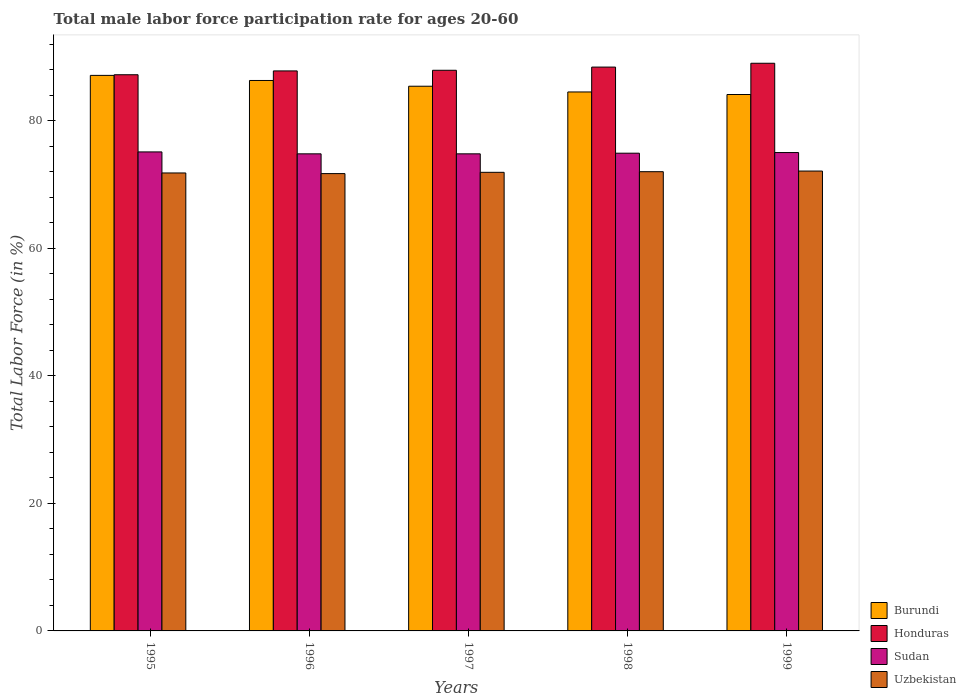Are the number of bars per tick equal to the number of legend labels?
Your answer should be compact. Yes. Are the number of bars on each tick of the X-axis equal?
Your response must be concise. Yes. How many bars are there on the 5th tick from the left?
Ensure brevity in your answer.  4. How many bars are there on the 5th tick from the right?
Your answer should be very brief. 4. What is the male labor force participation rate in Honduras in 1997?
Make the answer very short. 87.9. Across all years, what is the maximum male labor force participation rate in Uzbekistan?
Keep it short and to the point. 72.1. Across all years, what is the minimum male labor force participation rate in Burundi?
Provide a succinct answer. 84.1. In which year was the male labor force participation rate in Honduras maximum?
Keep it short and to the point. 1999. In which year was the male labor force participation rate in Burundi minimum?
Give a very brief answer. 1999. What is the total male labor force participation rate in Burundi in the graph?
Provide a short and direct response. 427.4. What is the difference between the male labor force participation rate in Honduras in 1995 and that in 1996?
Provide a succinct answer. -0.6. What is the difference between the male labor force participation rate in Sudan in 1997 and the male labor force participation rate in Burundi in 1995?
Your answer should be very brief. -12.3. What is the average male labor force participation rate in Sudan per year?
Keep it short and to the point. 74.92. In the year 1998, what is the difference between the male labor force participation rate in Uzbekistan and male labor force participation rate in Honduras?
Keep it short and to the point. -16.4. What is the ratio of the male labor force participation rate in Uzbekistan in 1995 to that in 1997?
Provide a short and direct response. 1. Is the difference between the male labor force participation rate in Uzbekistan in 1996 and 1998 greater than the difference between the male labor force participation rate in Honduras in 1996 and 1998?
Ensure brevity in your answer.  Yes. What is the difference between the highest and the second highest male labor force participation rate in Sudan?
Keep it short and to the point. 0.1. What is the difference between the highest and the lowest male labor force participation rate in Sudan?
Keep it short and to the point. 0.3. Is it the case that in every year, the sum of the male labor force participation rate in Honduras and male labor force participation rate in Sudan is greater than the sum of male labor force participation rate in Burundi and male labor force participation rate in Uzbekistan?
Make the answer very short. No. What does the 3rd bar from the left in 1997 represents?
Your answer should be very brief. Sudan. What does the 4th bar from the right in 1998 represents?
Provide a succinct answer. Burundi. Are all the bars in the graph horizontal?
Your answer should be compact. No. How many years are there in the graph?
Make the answer very short. 5. Does the graph contain any zero values?
Make the answer very short. No. What is the title of the graph?
Offer a very short reply. Total male labor force participation rate for ages 20-60. What is the Total Labor Force (in %) in Burundi in 1995?
Provide a succinct answer. 87.1. What is the Total Labor Force (in %) of Honduras in 1995?
Offer a terse response. 87.2. What is the Total Labor Force (in %) of Sudan in 1995?
Make the answer very short. 75.1. What is the Total Labor Force (in %) in Uzbekistan in 1995?
Offer a terse response. 71.8. What is the Total Labor Force (in %) of Burundi in 1996?
Offer a terse response. 86.3. What is the Total Labor Force (in %) in Honduras in 1996?
Give a very brief answer. 87.8. What is the Total Labor Force (in %) in Sudan in 1996?
Offer a very short reply. 74.8. What is the Total Labor Force (in %) of Uzbekistan in 1996?
Provide a short and direct response. 71.7. What is the Total Labor Force (in %) in Burundi in 1997?
Provide a short and direct response. 85.4. What is the Total Labor Force (in %) of Honduras in 1997?
Your answer should be very brief. 87.9. What is the Total Labor Force (in %) of Sudan in 1997?
Provide a short and direct response. 74.8. What is the Total Labor Force (in %) in Uzbekistan in 1997?
Your response must be concise. 71.9. What is the Total Labor Force (in %) in Burundi in 1998?
Provide a short and direct response. 84.5. What is the Total Labor Force (in %) of Honduras in 1998?
Ensure brevity in your answer.  88.4. What is the Total Labor Force (in %) in Sudan in 1998?
Ensure brevity in your answer.  74.9. What is the Total Labor Force (in %) in Uzbekistan in 1998?
Your answer should be compact. 72. What is the Total Labor Force (in %) in Burundi in 1999?
Make the answer very short. 84.1. What is the Total Labor Force (in %) in Honduras in 1999?
Your answer should be compact. 89. What is the Total Labor Force (in %) in Sudan in 1999?
Make the answer very short. 75. What is the Total Labor Force (in %) of Uzbekistan in 1999?
Your response must be concise. 72.1. Across all years, what is the maximum Total Labor Force (in %) in Burundi?
Offer a terse response. 87.1. Across all years, what is the maximum Total Labor Force (in %) of Honduras?
Offer a terse response. 89. Across all years, what is the maximum Total Labor Force (in %) in Sudan?
Keep it short and to the point. 75.1. Across all years, what is the maximum Total Labor Force (in %) in Uzbekistan?
Your answer should be compact. 72.1. Across all years, what is the minimum Total Labor Force (in %) of Burundi?
Give a very brief answer. 84.1. Across all years, what is the minimum Total Labor Force (in %) of Honduras?
Your answer should be very brief. 87.2. Across all years, what is the minimum Total Labor Force (in %) of Sudan?
Your response must be concise. 74.8. Across all years, what is the minimum Total Labor Force (in %) of Uzbekistan?
Your answer should be compact. 71.7. What is the total Total Labor Force (in %) of Burundi in the graph?
Ensure brevity in your answer.  427.4. What is the total Total Labor Force (in %) in Honduras in the graph?
Offer a very short reply. 440.3. What is the total Total Labor Force (in %) in Sudan in the graph?
Provide a succinct answer. 374.6. What is the total Total Labor Force (in %) of Uzbekistan in the graph?
Ensure brevity in your answer.  359.5. What is the difference between the Total Labor Force (in %) in Burundi in 1995 and that in 1996?
Provide a succinct answer. 0.8. What is the difference between the Total Labor Force (in %) of Honduras in 1995 and that in 1996?
Make the answer very short. -0.6. What is the difference between the Total Labor Force (in %) of Sudan in 1995 and that in 1996?
Your answer should be compact. 0.3. What is the difference between the Total Labor Force (in %) in Uzbekistan in 1995 and that in 1996?
Offer a terse response. 0.1. What is the difference between the Total Labor Force (in %) in Burundi in 1995 and that in 1997?
Your answer should be very brief. 1.7. What is the difference between the Total Labor Force (in %) of Honduras in 1995 and that in 1997?
Give a very brief answer. -0.7. What is the difference between the Total Labor Force (in %) in Sudan in 1995 and that in 1997?
Your answer should be compact. 0.3. What is the difference between the Total Labor Force (in %) in Burundi in 1995 and that in 1998?
Your response must be concise. 2.6. What is the difference between the Total Labor Force (in %) in Burundi in 1995 and that in 1999?
Make the answer very short. 3. What is the difference between the Total Labor Force (in %) of Sudan in 1995 and that in 1999?
Provide a short and direct response. 0.1. What is the difference between the Total Labor Force (in %) in Uzbekistan in 1996 and that in 1997?
Your answer should be very brief. -0.2. What is the difference between the Total Labor Force (in %) in Honduras in 1996 and that in 1998?
Ensure brevity in your answer.  -0.6. What is the difference between the Total Labor Force (in %) of Sudan in 1996 and that in 1998?
Offer a terse response. -0.1. What is the difference between the Total Labor Force (in %) of Uzbekistan in 1996 and that in 1998?
Offer a terse response. -0.3. What is the difference between the Total Labor Force (in %) of Sudan in 1996 and that in 1999?
Your answer should be very brief. -0.2. What is the difference between the Total Labor Force (in %) in Honduras in 1997 and that in 1998?
Make the answer very short. -0.5. What is the difference between the Total Labor Force (in %) of Sudan in 1997 and that in 1998?
Provide a succinct answer. -0.1. What is the difference between the Total Labor Force (in %) of Sudan in 1997 and that in 1999?
Keep it short and to the point. -0.2. What is the difference between the Total Labor Force (in %) of Uzbekistan in 1997 and that in 1999?
Ensure brevity in your answer.  -0.2. What is the difference between the Total Labor Force (in %) in Burundi in 1995 and the Total Labor Force (in %) in Sudan in 1996?
Your answer should be compact. 12.3. What is the difference between the Total Labor Force (in %) of Burundi in 1995 and the Total Labor Force (in %) of Uzbekistan in 1996?
Give a very brief answer. 15.4. What is the difference between the Total Labor Force (in %) of Honduras in 1995 and the Total Labor Force (in %) of Sudan in 1996?
Offer a terse response. 12.4. What is the difference between the Total Labor Force (in %) in Burundi in 1995 and the Total Labor Force (in %) in Honduras in 1997?
Provide a short and direct response. -0.8. What is the difference between the Total Labor Force (in %) in Burundi in 1995 and the Total Labor Force (in %) in Sudan in 1997?
Give a very brief answer. 12.3. What is the difference between the Total Labor Force (in %) in Burundi in 1995 and the Total Labor Force (in %) in Uzbekistan in 1997?
Give a very brief answer. 15.2. What is the difference between the Total Labor Force (in %) in Honduras in 1995 and the Total Labor Force (in %) in Sudan in 1997?
Offer a very short reply. 12.4. What is the difference between the Total Labor Force (in %) in Sudan in 1995 and the Total Labor Force (in %) in Uzbekistan in 1997?
Offer a terse response. 3.2. What is the difference between the Total Labor Force (in %) of Burundi in 1995 and the Total Labor Force (in %) of Uzbekistan in 1998?
Your answer should be very brief. 15.1. What is the difference between the Total Labor Force (in %) in Burundi in 1995 and the Total Labor Force (in %) in Honduras in 1999?
Make the answer very short. -1.9. What is the difference between the Total Labor Force (in %) of Burundi in 1995 and the Total Labor Force (in %) of Sudan in 1999?
Your answer should be very brief. 12.1. What is the difference between the Total Labor Force (in %) of Burundi in 1995 and the Total Labor Force (in %) of Uzbekistan in 1999?
Give a very brief answer. 15. What is the difference between the Total Labor Force (in %) in Sudan in 1995 and the Total Labor Force (in %) in Uzbekistan in 1999?
Make the answer very short. 3. What is the difference between the Total Labor Force (in %) of Burundi in 1996 and the Total Labor Force (in %) of Honduras in 1997?
Give a very brief answer. -1.6. What is the difference between the Total Labor Force (in %) of Burundi in 1996 and the Total Labor Force (in %) of Uzbekistan in 1997?
Keep it short and to the point. 14.4. What is the difference between the Total Labor Force (in %) in Honduras in 1996 and the Total Labor Force (in %) in Sudan in 1997?
Provide a short and direct response. 13. What is the difference between the Total Labor Force (in %) in Sudan in 1996 and the Total Labor Force (in %) in Uzbekistan in 1997?
Keep it short and to the point. 2.9. What is the difference between the Total Labor Force (in %) in Burundi in 1996 and the Total Labor Force (in %) in Uzbekistan in 1998?
Offer a terse response. 14.3. What is the difference between the Total Labor Force (in %) of Honduras in 1996 and the Total Labor Force (in %) of Uzbekistan in 1998?
Offer a terse response. 15.8. What is the difference between the Total Labor Force (in %) in Burundi in 1996 and the Total Labor Force (in %) in Sudan in 1999?
Your answer should be compact. 11.3. What is the difference between the Total Labor Force (in %) of Honduras in 1996 and the Total Labor Force (in %) of Sudan in 1999?
Give a very brief answer. 12.8. What is the difference between the Total Labor Force (in %) of Honduras in 1996 and the Total Labor Force (in %) of Uzbekistan in 1999?
Provide a succinct answer. 15.7. What is the difference between the Total Labor Force (in %) of Honduras in 1997 and the Total Labor Force (in %) of Sudan in 1998?
Keep it short and to the point. 13. What is the difference between the Total Labor Force (in %) of Honduras in 1997 and the Total Labor Force (in %) of Uzbekistan in 1998?
Your answer should be compact. 15.9. What is the difference between the Total Labor Force (in %) of Burundi in 1997 and the Total Labor Force (in %) of Sudan in 1999?
Ensure brevity in your answer.  10.4. What is the difference between the Total Labor Force (in %) in Burundi in 1997 and the Total Labor Force (in %) in Uzbekistan in 1999?
Your answer should be compact. 13.3. What is the difference between the Total Labor Force (in %) in Sudan in 1997 and the Total Labor Force (in %) in Uzbekistan in 1999?
Offer a terse response. 2.7. What is the difference between the Total Labor Force (in %) in Burundi in 1998 and the Total Labor Force (in %) in Sudan in 1999?
Keep it short and to the point. 9.5. What is the difference between the Total Labor Force (in %) of Honduras in 1998 and the Total Labor Force (in %) of Uzbekistan in 1999?
Provide a succinct answer. 16.3. What is the difference between the Total Labor Force (in %) of Sudan in 1998 and the Total Labor Force (in %) of Uzbekistan in 1999?
Offer a very short reply. 2.8. What is the average Total Labor Force (in %) of Burundi per year?
Offer a terse response. 85.48. What is the average Total Labor Force (in %) of Honduras per year?
Provide a succinct answer. 88.06. What is the average Total Labor Force (in %) of Sudan per year?
Your answer should be compact. 74.92. What is the average Total Labor Force (in %) of Uzbekistan per year?
Keep it short and to the point. 71.9. In the year 1995, what is the difference between the Total Labor Force (in %) in Burundi and Total Labor Force (in %) in Honduras?
Offer a very short reply. -0.1. In the year 1995, what is the difference between the Total Labor Force (in %) in Burundi and Total Labor Force (in %) in Uzbekistan?
Offer a terse response. 15.3. In the year 1995, what is the difference between the Total Labor Force (in %) of Honduras and Total Labor Force (in %) of Sudan?
Offer a terse response. 12.1. In the year 1995, what is the difference between the Total Labor Force (in %) in Sudan and Total Labor Force (in %) in Uzbekistan?
Your response must be concise. 3.3. In the year 1996, what is the difference between the Total Labor Force (in %) in Burundi and Total Labor Force (in %) in Honduras?
Your answer should be compact. -1.5. In the year 1996, what is the difference between the Total Labor Force (in %) of Burundi and Total Labor Force (in %) of Sudan?
Your answer should be very brief. 11.5. In the year 1997, what is the difference between the Total Labor Force (in %) in Honduras and Total Labor Force (in %) in Uzbekistan?
Make the answer very short. 16. In the year 1998, what is the difference between the Total Labor Force (in %) in Burundi and Total Labor Force (in %) in Honduras?
Your response must be concise. -3.9. In the year 1998, what is the difference between the Total Labor Force (in %) of Burundi and Total Labor Force (in %) of Sudan?
Provide a short and direct response. 9.6. In the year 1998, what is the difference between the Total Labor Force (in %) of Honduras and Total Labor Force (in %) of Sudan?
Provide a short and direct response. 13.5. In the year 1999, what is the difference between the Total Labor Force (in %) in Burundi and Total Labor Force (in %) in Honduras?
Provide a succinct answer. -4.9. In the year 1999, what is the difference between the Total Labor Force (in %) in Burundi and Total Labor Force (in %) in Sudan?
Provide a short and direct response. 9.1. In the year 1999, what is the difference between the Total Labor Force (in %) in Burundi and Total Labor Force (in %) in Uzbekistan?
Provide a succinct answer. 12. In the year 1999, what is the difference between the Total Labor Force (in %) in Honduras and Total Labor Force (in %) in Uzbekistan?
Ensure brevity in your answer.  16.9. In the year 1999, what is the difference between the Total Labor Force (in %) of Sudan and Total Labor Force (in %) of Uzbekistan?
Ensure brevity in your answer.  2.9. What is the ratio of the Total Labor Force (in %) of Burundi in 1995 to that in 1996?
Provide a succinct answer. 1.01. What is the ratio of the Total Labor Force (in %) of Honduras in 1995 to that in 1996?
Your answer should be compact. 0.99. What is the ratio of the Total Labor Force (in %) of Burundi in 1995 to that in 1997?
Make the answer very short. 1.02. What is the ratio of the Total Labor Force (in %) in Burundi in 1995 to that in 1998?
Ensure brevity in your answer.  1.03. What is the ratio of the Total Labor Force (in %) in Honduras in 1995 to that in 1998?
Your response must be concise. 0.99. What is the ratio of the Total Labor Force (in %) in Sudan in 1995 to that in 1998?
Give a very brief answer. 1. What is the ratio of the Total Labor Force (in %) of Uzbekistan in 1995 to that in 1998?
Offer a terse response. 1. What is the ratio of the Total Labor Force (in %) in Burundi in 1995 to that in 1999?
Your answer should be very brief. 1.04. What is the ratio of the Total Labor Force (in %) in Honduras in 1995 to that in 1999?
Your answer should be compact. 0.98. What is the ratio of the Total Labor Force (in %) of Burundi in 1996 to that in 1997?
Your answer should be very brief. 1.01. What is the ratio of the Total Labor Force (in %) of Honduras in 1996 to that in 1997?
Your answer should be very brief. 1. What is the ratio of the Total Labor Force (in %) of Burundi in 1996 to that in 1998?
Ensure brevity in your answer.  1.02. What is the ratio of the Total Labor Force (in %) of Honduras in 1996 to that in 1998?
Offer a terse response. 0.99. What is the ratio of the Total Labor Force (in %) of Uzbekistan in 1996 to that in 1998?
Give a very brief answer. 1. What is the ratio of the Total Labor Force (in %) in Burundi in 1996 to that in 1999?
Offer a very short reply. 1.03. What is the ratio of the Total Labor Force (in %) in Honduras in 1996 to that in 1999?
Give a very brief answer. 0.99. What is the ratio of the Total Labor Force (in %) in Sudan in 1996 to that in 1999?
Give a very brief answer. 1. What is the ratio of the Total Labor Force (in %) in Burundi in 1997 to that in 1998?
Ensure brevity in your answer.  1.01. What is the ratio of the Total Labor Force (in %) of Honduras in 1997 to that in 1998?
Ensure brevity in your answer.  0.99. What is the ratio of the Total Labor Force (in %) of Burundi in 1997 to that in 1999?
Give a very brief answer. 1.02. What is the ratio of the Total Labor Force (in %) of Honduras in 1997 to that in 1999?
Your answer should be very brief. 0.99. What is the ratio of the Total Labor Force (in %) of Sudan in 1997 to that in 1999?
Provide a succinct answer. 1. What is the ratio of the Total Labor Force (in %) of Uzbekistan in 1997 to that in 1999?
Offer a terse response. 1. What is the ratio of the Total Labor Force (in %) in Burundi in 1998 to that in 1999?
Your answer should be compact. 1. What is the ratio of the Total Labor Force (in %) in Uzbekistan in 1998 to that in 1999?
Keep it short and to the point. 1. What is the difference between the highest and the second highest Total Labor Force (in %) of Sudan?
Provide a succinct answer. 0.1. What is the difference between the highest and the lowest Total Labor Force (in %) of Burundi?
Provide a succinct answer. 3. What is the difference between the highest and the lowest Total Labor Force (in %) in Honduras?
Give a very brief answer. 1.8. What is the difference between the highest and the lowest Total Labor Force (in %) of Uzbekistan?
Make the answer very short. 0.4. 